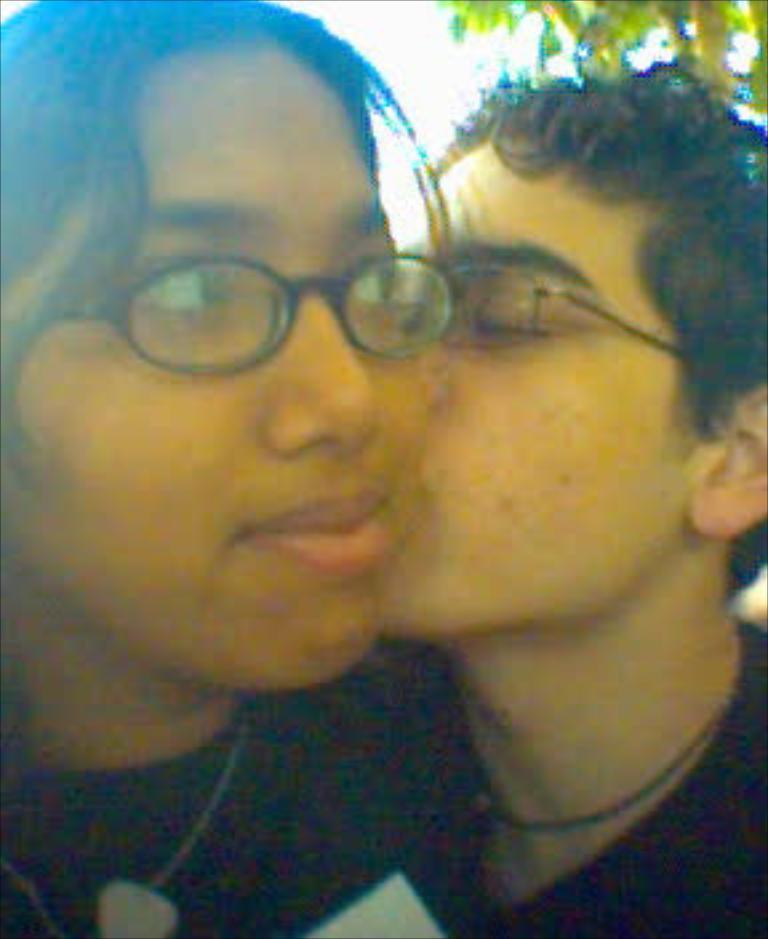What is the main subject of the image? There is a boy in the image. What is the boy doing in the image? The boy is kissing a girl. What type of regret can be seen on the boy's chin in the image? There is no regret visible on the boy's chin in the image, as the provided facts do not mention any emotions or expressions. 